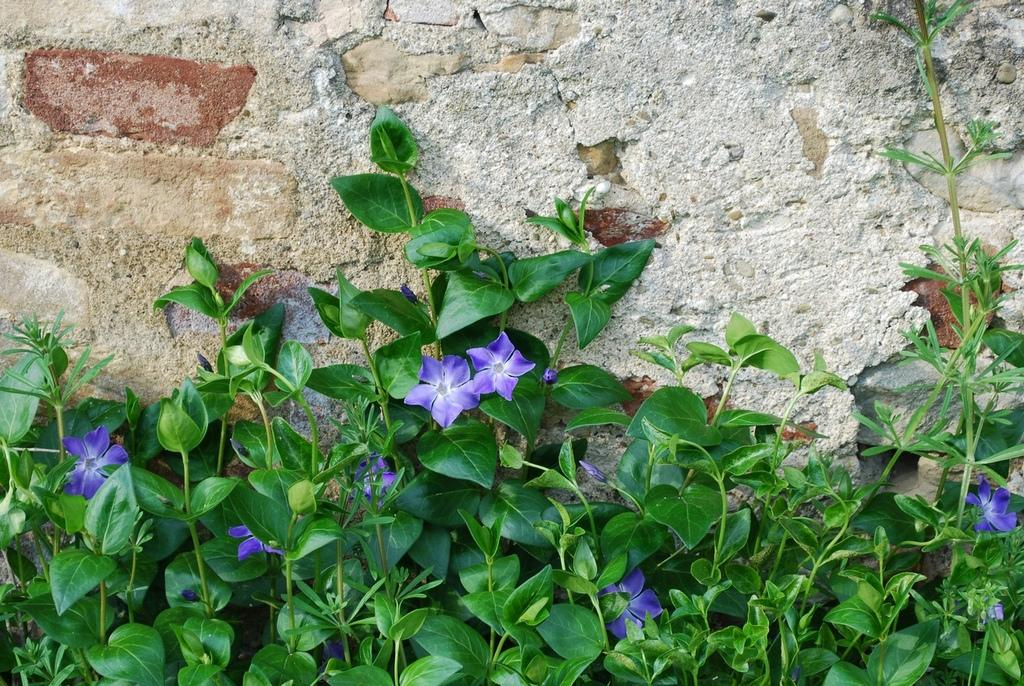What type of living organisms can be seen in the image? Plants and flowers are visible in the image. What is the background or surrounding structure in the image? There is a brick wall in the image. What type of alley can be seen in the image? There is no alley present in the image; it features plants, flowers, and a brick wall. Is there a prison visible in the image? There is no prison present in the image; it features plants, flowers, and a brick wall. 